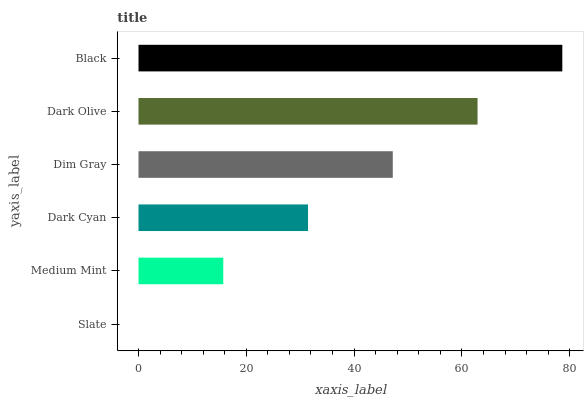Is Slate the minimum?
Answer yes or no. Yes. Is Black the maximum?
Answer yes or no. Yes. Is Medium Mint the minimum?
Answer yes or no. No. Is Medium Mint the maximum?
Answer yes or no. No. Is Medium Mint greater than Slate?
Answer yes or no. Yes. Is Slate less than Medium Mint?
Answer yes or no. Yes. Is Slate greater than Medium Mint?
Answer yes or no. No. Is Medium Mint less than Slate?
Answer yes or no. No. Is Dim Gray the high median?
Answer yes or no. Yes. Is Dark Cyan the low median?
Answer yes or no. Yes. Is Dark Cyan the high median?
Answer yes or no. No. Is Medium Mint the low median?
Answer yes or no. No. 